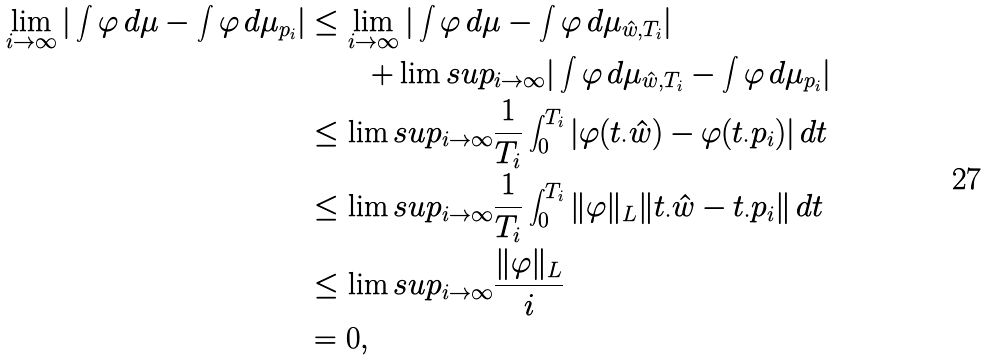<formula> <loc_0><loc_0><loc_500><loc_500>\lim _ { i \to \infty } | \int \varphi \, d \mu - \int \varphi \, d \mu _ { p _ { i } } | & \leq \lim _ { i \to \infty } | \int \varphi \, d \mu - \int \varphi \, d \mu _ { \hat { w } , T _ { i } } | \\ & { \quad } \quad + \lim s u p _ { i \to \infty } | \int \varphi \, d \mu _ { \hat { w } , T _ { i } } - \int \varphi \, d \mu _ { p _ { i } } | \\ & \leq \lim s u p _ { i \to \infty } \frac { 1 } { T _ { i } } \int _ { 0 } ^ { T _ { i } } | \varphi ( t _ { \cdot } \hat { w } ) - \varphi ( t _ { \cdot } p _ { i } ) | \, d t \\ & \leq \lim s u p _ { i \to \infty } \frac { 1 } { T _ { i } } \int _ { 0 } ^ { T _ { i } } \| \varphi \| _ { L } \| t _ { \cdot } \hat { w } - t _ { \cdot } p _ { i } \| \, d t \\ & \leq \lim s u p _ { i \to \infty } \frac { \| \varphi \| _ { L } } { i } \\ & = 0 ,</formula> 